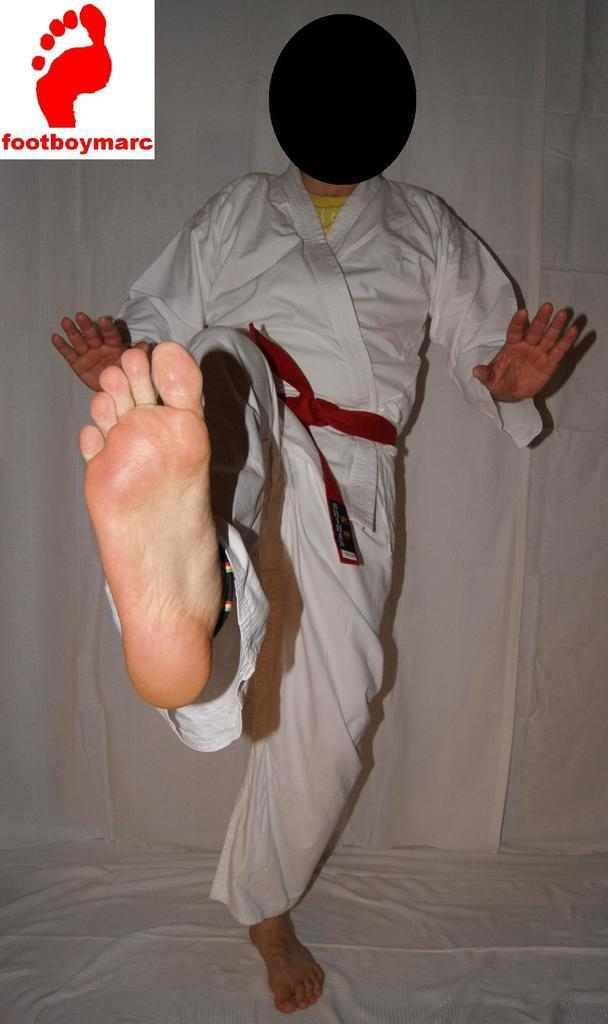What is: What is the main subject in the foreground of the image? There is a person in the foreground of the image. What is the person doing in the image? The person is standing on one foot in the image. What can be seen in the background of the image? There is a white cloth in the background of the image. Can you tell me how many goats are swimming in the lake in the image? There is no lake or goats present in the image; it features a person standing on one foot with a white cloth in the background. 